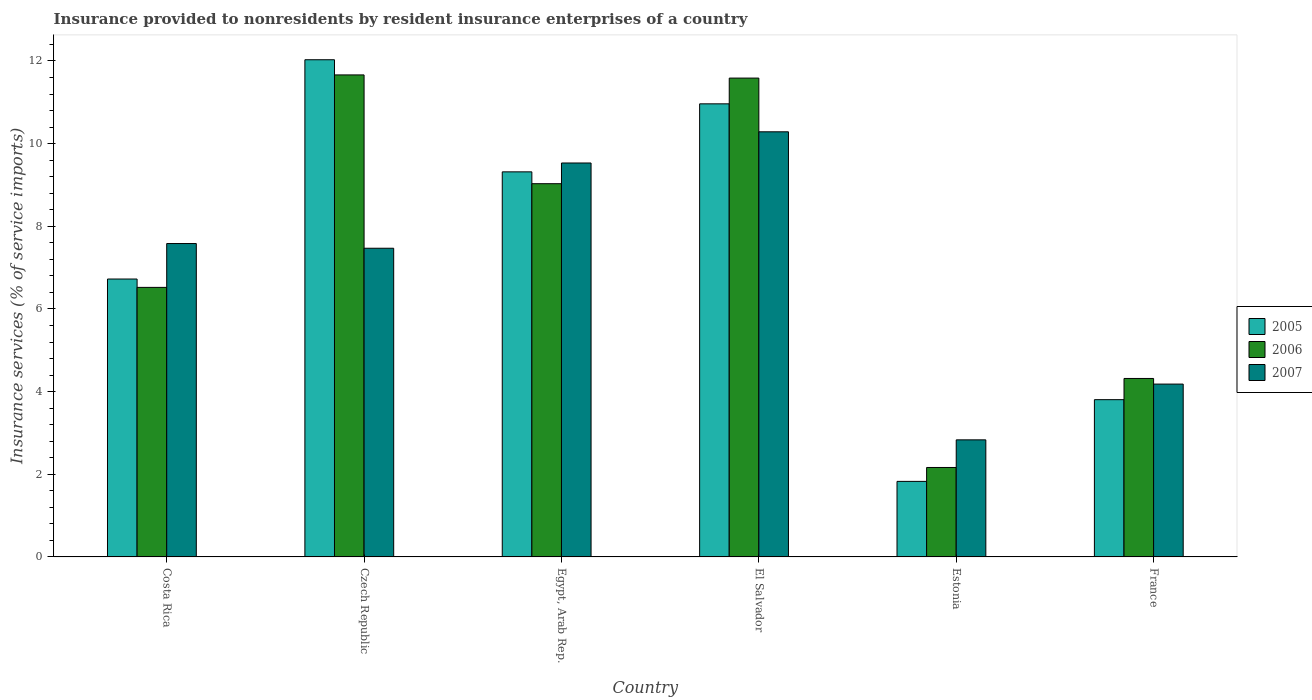How many groups of bars are there?
Your answer should be very brief. 6. How many bars are there on the 3rd tick from the right?
Provide a short and direct response. 3. What is the label of the 5th group of bars from the left?
Offer a very short reply. Estonia. In how many cases, is the number of bars for a given country not equal to the number of legend labels?
Offer a very short reply. 0. What is the insurance provided to nonresidents in 2005 in France?
Your response must be concise. 3.81. Across all countries, what is the maximum insurance provided to nonresidents in 2005?
Provide a succinct answer. 12.03. Across all countries, what is the minimum insurance provided to nonresidents in 2007?
Ensure brevity in your answer.  2.83. In which country was the insurance provided to nonresidents in 2006 maximum?
Provide a short and direct response. Czech Republic. In which country was the insurance provided to nonresidents in 2007 minimum?
Keep it short and to the point. Estonia. What is the total insurance provided to nonresidents in 2005 in the graph?
Ensure brevity in your answer.  44.66. What is the difference between the insurance provided to nonresidents in 2006 in Costa Rica and that in Egypt, Arab Rep.?
Keep it short and to the point. -2.51. What is the difference between the insurance provided to nonresidents in 2006 in Costa Rica and the insurance provided to nonresidents in 2007 in France?
Keep it short and to the point. 2.34. What is the average insurance provided to nonresidents in 2005 per country?
Provide a short and direct response. 7.44. What is the difference between the insurance provided to nonresidents of/in 2005 and insurance provided to nonresidents of/in 2006 in Estonia?
Keep it short and to the point. -0.34. In how many countries, is the insurance provided to nonresidents in 2005 greater than 2 %?
Your answer should be compact. 5. What is the ratio of the insurance provided to nonresidents in 2005 in Egypt, Arab Rep. to that in France?
Keep it short and to the point. 2.45. What is the difference between the highest and the second highest insurance provided to nonresidents in 2007?
Keep it short and to the point. -0.75. What is the difference between the highest and the lowest insurance provided to nonresidents in 2006?
Offer a very short reply. 9.5. What does the 1st bar from the left in Costa Rica represents?
Offer a terse response. 2005. What does the 3rd bar from the right in Estonia represents?
Make the answer very short. 2005. How many bars are there?
Provide a succinct answer. 18. Are all the bars in the graph horizontal?
Ensure brevity in your answer.  No. Does the graph contain grids?
Offer a terse response. No. How are the legend labels stacked?
Your response must be concise. Vertical. What is the title of the graph?
Offer a terse response. Insurance provided to nonresidents by resident insurance enterprises of a country. What is the label or title of the X-axis?
Offer a terse response. Country. What is the label or title of the Y-axis?
Your answer should be compact. Insurance services (% of service imports). What is the Insurance services (% of service imports) in 2005 in Costa Rica?
Offer a terse response. 6.72. What is the Insurance services (% of service imports) of 2006 in Costa Rica?
Your answer should be very brief. 6.52. What is the Insurance services (% of service imports) in 2007 in Costa Rica?
Give a very brief answer. 7.58. What is the Insurance services (% of service imports) of 2005 in Czech Republic?
Offer a very short reply. 12.03. What is the Insurance services (% of service imports) in 2006 in Czech Republic?
Offer a terse response. 11.66. What is the Insurance services (% of service imports) in 2007 in Czech Republic?
Keep it short and to the point. 7.47. What is the Insurance services (% of service imports) in 2005 in Egypt, Arab Rep.?
Provide a short and direct response. 9.32. What is the Insurance services (% of service imports) in 2006 in Egypt, Arab Rep.?
Ensure brevity in your answer.  9.03. What is the Insurance services (% of service imports) in 2007 in Egypt, Arab Rep.?
Offer a terse response. 9.53. What is the Insurance services (% of service imports) of 2005 in El Salvador?
Your answer should be very brief. 10.96. What is the Insurance services (% of service imports) of 2006 in El Salvador?
Make the answer very short. 11.59. What is the Insurance services (% of service imports) in 2007 in El Salvador?
Provide a short and direct response. 10.29. What is the Insurance services (% of service imports) of 2005 in Estonia?
Offer a very short reply. 1.83. What is the Insurance services (% of service imports) in 2006 in Estonia?
Your response must be concise. 2.16. What is the Insurance services (% of service imports) of 2007 in Estonia?
Provide a succinct answer. 2.83. What is the Insurance services (% of service imports) in 2005 in France?
Your response must be concise. 3.81. What is the Insurance services (% of service imports) of 2006 in France?
Keep it short and to the point. 4.32. What is the Insurance services (% of service imports) in 2007 in France?
Ensure brevity in your answer.  4.18. Across all countries, what is the maximum Insurance services (% of service imports) in 2005?
Offer a very short reply. 12.03. Across all countries, what is the maximum Insurance services (% of service imports) in 2006?
Keep it short and to the point. 11.66. Across all countries, what is the maximum Insurance services (% of service imports) in 2007?
Offer a very short reply. 10.29. Across all countries, what is the minimum Insurance services (% of service imports) in 2005?
Provide a short and direct response. 1.83. Across all countries, what is the minimum Insurance services (% of service imports) in 2006?
Ensure brevity in your answer.  2.16. Across all countries, what is the minimum Insurance services (% of service imports) in 2007?
Ensure brevity in your answer.  2.83. What is the total Insurance services (% of service imports) of 2005 in the graph?
Ensure brevity in your answer.  44.66. What is the total Insurance services (% of service imports) in 2006 in the graph?
Offer a very short reply. 45.28. What is the total Insurance services (% of service imports) of 2007 in the graph?
Your answer should be compact. 41.88. What is the difference between the Insurance services (% of service imports) of 2005 in Costa Rica and that in Czech Republic?
Your response must be concise. -5.31. What is the difference between the Insurance services (% of service imports) in 2006 in Costa Rica and that in Czech Republic?
Offer a terse response. -5.14. What is the difference between the Insurance services (% of service imports) of 2007 in Costa Rica and that in Czech Republic?
Provide a succinct answer. 0.11. What is the difference between the Insurance services (% of service imports) in 2005 in Costa Rica and that in Egypt, Arab Rep.?
Offer a very short reply. -2.59. What is the difference between the Insurance services (% of service imports) in 2006 in Costa Rica and that in Egypt, Arab Rep.?
Ensure brevity in your answer.  -2.51. What is the difference between the Insurance services (% of service imports) of 2007 in Costa Rica and that in Egypt, Arab Rep.?
Provide a short and direct response. -1.95. What is the difference between the Insurance services (% of service imports) in 2005 in Costa Rica and that in El Salvador?
Give a very brief answer. -4.24. What is the difference between the Insurance services (% of service imports) in 2006 in Costa Rica and that in El Salvador?
Provide a short and direct response. -5.06. What is the difference between the Insurance services (% of service imports) of 2007 in Costa Rica and that in El Salvador?
Your answer should be compact. -2.7. What is the difference between the Insurance services (% of service imports) in 2005 in Costa Rica and that in Estonia?
Offer a terse response. 4.9. What is the difference between the Insurance services (% of service imports) of 2006 in Costa Rica and that in Estonia?
Give a very brief answer. 4.36. What is the difference between the Insurance services (% of service imports) in 2007 in Costa Rica and that in Estonia?
Give a very brief answer. 4.75. What is the difference between the Insurance services (% of service imports) in 2005 in Costa Rica and that in France?
Offer a terse response. 2.92. What is the difference between the Insurance services (% of service imports) in 2006 in Costa Rica and that in France?
Offer a terse response. 2.2. What is the difference between the Insurance services (% of service imports) of 2007 in Costa Rica and that in France?
Keep it short and to the point. 3.4. What is the difference between the Insurance services (% of service imports) of 2005 in Czech Republic and that in Egypt, Arab Rep.?
Your response must be concise. 2.71. What is the difference between the Insurance services (% of service imports) of 2006 in Czech Republic and that in Egypt, Arab Rep.?
Make the answer very short. 2.63. What is the difference between the Insurance services (% of service imports) of 2007 in Czech Republic and that in Egypt, Arab Rep.?
Offer a very short reply. -2.06. What is the difference between the Insurance services (% of service imports) in 2005 in Czech Republic and that in El Salvador?
Ensure brevity in your answer.  1.07. What is the difference between the Insurance services (% of service imports) in 2006 in Czech Republic and that in El Salvador?
Keep it short and to the point. 0.08. What is the difference between the Insurance services (% of service imports) of 2007 in Czech Republic and that in El Salvador?
Your response must be concise. -2.82. What is the difference between the Insurance services (% of service imports) in 2005 in Czech Republic and that in Estonia?
Offer a terse response. 10.2. What is the difference between the Insurance services (% of service imports) of 2006 in Czech Republic and that in Estonia?
Keep it short and to the point. 9.5. What is the difference between the Insurance services (% of service imports) in 2007 in Czech Republic and that in Estonia?
Your answer should be very brief. 4.64. What is the difference between the Insurance services (% of service imports) in 2005 in Czech Republic and that in France?
Provide a succinct answer. 8.22. What is the difference between the Insurance services (% of service imports) in 2006 in Czech Republic and that in France?
Your answer should be compact. 7.34. What is the difference between the Insurance services (% of service imports) in 2007 in Czech Republic and that in France?
Your answer should be very brief. 3.29. What is the difference between the Insurance services (% of service imports) in 2005 in Egypt, Arab Rep. and that in El Salvador?
Your response must be concise. -1.65. What is the difference between the Insurance services (% of service imports) of 2006 in Egypt, Arab Rep. and that in El Salvador?
Provide a short and direct response. -2.56. What is the difference between the Insurance services (% of service imports) in 2007 in Egypt, Arab Rep. and that in El Salvador?
Make the answer very short. -0.75. What is the difference between the Insurance services (% of service imports) in 2005 in Egypt, Arab Rep. and that in Estonia?
Make the answer very short. 7.49. What is the difference between the Insurance services (% of service imports) of 2006 in Egypt, Arab Rep. and that in Estonia?
Give a very brief answer. 6.87. What is the difference between the Insurance services (% of service imports) of 2007 in Egypt, Arab Rep. and that in Estonia?
Keep it short and to the point. 6.7. What is the difference between the Insurance services (% of service imports) of 2005 in Egypt, Arab Rep. and that in France?
Ensure brevity in your answer.  5.51. What is the difference between the Insurance services (% of service imports) in 2006 in Egypt, Arab Rep. and that in France?
Offer a terse response. 4.71. What is the difference between the Insurance services (% of service imports) in 2007 in Egypt, Arab Rep. and that in France?
Offer a very short reply. 5.35. What is the difference between the Insurance services (% of service imports) of 2005 in El Salvador and that in Estonia?
Your answer should be compact. 9.13. What is the difference between the Insurance services (% of service imports) of 2006 in El Salvador and that in Estonia?
Offer a terse response. 9.42. What is the difference between the Insurance services (% of service imports) of 2007 in El Salvador and that in Estonia?
Ensure brevity in your answer.  7.45. What is the difference between the Insurance services (% of service imports) of 2005 in El Salvador and that in France?
Your answer should be very brief. 7.16. What is the difference between the Insurance services (% of service imports) in 2006 in El Salvador and that in France?
Your answer should be compact. 7.27. What is the difference between the Insurance services (% of service imports) in 2007 in El Salvador and that in France?
Your answer should be very brief. 6.1. What is the difference between the Insurance services (% of service imports) in 2005 in Estonia and that in France?
Provide a short and direct response. -1.98. What is the difference between the Insurance services (% of service imports) in 2006 in Estonia and that in France?
Provide a short and direct response. -2.15. What is the difference between the Insurance services (% of service imports) of 2007 in Estonia and that in France?
Your answer should be very brief. -1.35. What is the difference between the Insurance services (% of service imports) in 2005 in Costa Rica and the Insurance services (% of service imports) in 2006 in Czech Republic?
Make the answer very short. -4.94. What is the difference between the Insurance services (% of service imports) of 2005 in Costa Rica and the Insurance services (% of service imports) of 2007 in Czech Republic?
Make the answer very short. -0.74. What is the difference between the Insurance services (% of service imports) in 2006 in Costa Rica and the Insurance services (% of service imports) in 2007 in Czech Republic?
Make the answer very short. -0.95. What is the difference between the Insurance services (% of service imports) of 2005 in Costa Rica and the Insurance services (% of service imports) of 2006 in Egypt, Arab Rep.?
Your response must be concise. -2.31. What is the difference between the Insurance services (% of service imports) in 2005 in Costa Rica and the Insurance services (% of service imports) in 2007 in Egypt, Arab Rep.?
Give a very brief answer. -2.81. What is the difference between the Insurance services (% of service imports) of 2006 in Costa Rica and the Insurance services (% of service imports) of 2007 in Egypt, Arab Rep.?
Your answer should be compact. -3.01. What is the difference between the Insurance services (% of service imports) of 2005 in Costa Rica and the Insurance services (% of service imports) of 2006 in El Salvador?
Provide a short and direct response. -4.86. What is the difference between the Insurance services (% of service imports) of 2005 in Costa Rica and the Insurance services (% of service imports) of 2007 in El Salvador?
Offer a terse response. -3.56. What is the difference between the Insurance services (% of service imports) of 2006 in Costa Rica and the Insurance services (% of service imports) of 2007 in El Salvador?
Keep it short and to the point. -3.76. What is the difference between the Insurance services (% of service imports) of 2005 in Costa Rica and the Insurance services (% of service imports) of 2006 in Estonia?
Make the answer very short. 4.56. What is the difference between the Insurance services (% of service imports) in 2005 in Costa Rica and the Insurance services (% of service imports) in 2007 in Estonia?
Ensure brevity in your answer.  3.89. What is the difference between the Insurance services (% of service imports) of 2006 in Costa Rica and the Insurance services (% of service imports) of 2007 in Estonia?
Keep it short and to the point. 3.69. What is the difference between the Insurance services (% of service imports) in 2005 in Costa Rica and the Insurance services (% of service imports) in 2006 in France?
Offer a very short reply. 2.41. What is the difference between the Insurance services (% of service imports) of 2005 in Costa Rica and the Insurance services (% of service imports) of 2007 in France?
Ensure brevity in your answer.  2.54. What is the difference between the Insurance services (% of service imports) of 2006 in Costa Rica and the Insurance services (% of service imports) of 2007 in France?
Your response must be concise. 2.34. What is the difference between the Insurance services (% of service imports) of 2005 in Czech Republic and the Insurance services (% of service imports) of 2006 in Egypt, Arab Rep.?
Your response must be concise. 3. What is the difference between the Insurance services (% of service imports) in 2005 in Czech Republic and the Insurance services (% of service imports) in 2007 in Egypt, Arab Rep.?
Offer a terse response. 2.5. What is the difference between the Insurance services (% of service imports) in 2006 in Czech Republic and the Insurance services (% of service imports) in 2007 in Egypt, Arab Rep.?
Provide a short and direct response. 2.13. What is the difference between the Insurance services (% of service imports) of 2005 in Czech Republic and the Insurance services (% of service imports) of 2006 in El Salvador?
Provide a succinct answer. 0.44. What is the difference between the Insurance services (% of service imports) in 2005 in Czech Republic and the Insurance services (% of service imports) in 2007 in El Salvador?
Provide a succinct answer. 1.74. What is the difference between the Insurance services (% of service imports) in 2006 in Czech Republic and the Insurance services (% of service imports) in 2007 in El Salvador?
Offer a terse response. 1.38. What is the difference between the Insurance services (% of service imports) in 2005 in Czech Republic and the Insurance services (% of service imports) in 2006 in Estonia?
Make the answer very short. 9.87. What is the difference between the Insurance services (% of service imports) of 2005 in Czech Republic and the Insurance services (% of service imports) of 2007 in Estonia?
Provide a succinct answer. 9.2. What is the difference between the Insurance services (% of service imports) of 2006 in Czech Republic and the Insurance services (% of service imports) of 2007 in Estonia?
Offer a very short reply. 8.83. What is the difference between the Insurance services (% of service imports) in 2005 in Czech Republic and the Insurance services (% of service imports) in 2006 in France?
Make the answer very short. 7.71. What is the difference between the Insurance services (% of service imports) of 2005 in Czech Republic and the Insurance services (% of service imports) of 2007 in France?
Your answer should be very brief. 7.85. What is the difference between the Insurance services (% of service imports) of 2006 in Czech Republic and the Insurance services (% of service imports) of 2007 in France?
Provide a succinct answer. 7.48. What is the difference between the Insurance services (% of service imports) of 2005 in Egypt, Arab Rep. and the Insurance services (% of service imports) of 2006 in El Salvador?
Offer a terse response. -2.27. What is the difference between the Insurance services (% of service imports) of 2005 in Egypt, Arab Rep. and the Insurance services (% of service imports) of 2007 in El Salvador?
Offer a terse response. -0.97. What is the difference between the Insurance services (% of service imports) of 2006 in Egypt, Arab Rep. and the Insurance services (% of service imports) of 2007 in El Salvador?
Offer a terse response. -1.26. What is the difference between the Insurance services (% of service imports) in 2005 in Egypt, Arab Rep. and the Insurance services (% of service imports) in 2006 in Estonia?
Offer a very short reply. 7.15. What is the difference between the Insurance services (% of service imports) of 2005 in Egypt, Arab Rep. and the Insurance services (% of service imports) of 2007 in Estonia?
Make the answer very short. 6.48. What is the difference between the Insurance services (% of service imports) of 2006 in Egypt, Arab Rep. and the Insurance services (% of service imports) of 2007 in Estonia?
Offer a very short reply. 6.2. What is the difference between the Insurance services (% of service imports) of 2005 in Egypt, Arab Rep. and the Insurance services (% of service imports) of 2006 in France?
Give a very brief answer. 5. What is the difference between the Insurance services (% of service imports) in 2005 in Egypt, Arab Rep. and the Insurance services (% of service imports) in 2007 in France?
Your answer should be compact. 5.13. What is the difference between the Insurance services (% of service imports) in 2006 in Egypt, Arab Rep. and the Insurance services (% of service imports) in 2007 in France?
Ensure brevity in your answer.  4.85. What is the difference between the Insurance services (% of service imports) of 2005 in El Salvador and the Insurance services (% of service imports) of 2006 in Estonia?
Make the answer very short. 8.8. What is the difference between the Insurance services (% of service imports) of 2005 in El Salvador and the Insurance services (% of service imports) of 2007 in Estonia?
Your answer should be compact. 8.13. What is the difference between the Insurance services (% of service imports) in 2006 in El Salvador and the Insurance services (% of service imports) in 2007 in Estonia?
Your response must be concise. 8.75. What is the difference between the Insurance services (% of service imports) in 2005 in El Salvador and the Insurance services (% of service imports) in 2006 in France?
Provide a succinct answer. 6.64. What is the difference between the Insurance services (% of service imports) of 2005 in El Salvador and the Insurance services (% of service imports) of 2007 in France?
Your response must be concise. 6.78. What is the difference between the Insurance services (% of service imports) of 2006 in El Salvador and the Insurance services (% of service imports) of 2007 in France?
Keep it short and to the point. 7.4. What is the difference between the Insurance services (% of service imports) in 2005 in Estonia and the Insurance services (% of service imports) in 2006 in France?
Your answer should be compact. -2.49. What is the difference between the Insurance services (% of service imports) in 2005 in Estonia and the Insurance services (% of service imports) in 2007 in France?
Your response must be concise. -2.35. What is the difference between the Insurance services (% of service imports) in 2006 in Estonia and the Insurance services (% of service imports) in 2007 in France?
Your answer should be very brief. -2.02. What is the average Insurance services (% of service imports) of 2005 per country?
Your answer should be very brief. 7.44. What is the average Insurance services (% of service imports) in 2006 per country?
Keep it short and to the point. 7.55. What is the average Insurance services (% of service imports) of 2007 per country?
Your response must be concise. 6.98. What is the difference between the Insurance services (% of service imports) in 2005 and Insurance services (% of service imports) in 2006 in Costa Rica?
Ensure brevity in your answer.  0.2. What is the difference between the Insurance services (% of service imports) of 2005 and Insurance services (% of service imports) of 2007 in Costa Rica?
Your response must be concise. -0.86. What is the difference between the Insurance services (% of service imports) in 2006 and Insurance services (% of service imports) in 2007 in Costa Rica?
Keep it short and to the point. -1.06. What is the difference between the Insurance services (% of service imports) of 2005 and Insurance services (% of service imports) of 2006 in Czech Republic?
Offer a very short reply. 0.37. What is the difference between the Insurance services (% of service imports) of 2005 and Insurance services (% of service imports) of 2007 in Czech Republic?
Provide a short and direct response. 4.56. What is the difference between the Insurance services (% of service imports) of 2006 and Insurance services (% of service imports) of 2007 in Czech Republic?
Keep it short and to the point. 4.19. What is the difference between the Insurance services (% of service imports) in 2005 and Insurance services (% of service imports) in 2006 in Egypt, Arab Rep.?
Ensure brevity in your answer.  0.29. What is the difference between the Insurance services (% of service imports) of 2005 and Insurance services (% of service imports) of 2007 in Egypt, Arab Rep.?
Keep it short and to the point. -0.21. What is the difference between the Insurance services (% of service imports) of 2006 and Insurance services (% of service imports) of 2007 in Egypt, Arab Rep.?
Give a very brief answer. -0.5. What is the difference between the Insurance services (% of service imports) of 2005 and Insurance services (% of service imports) of 2006 in El Salvador?
Keep it short and to the point. -0.62. What is the difference between the Insurance services (% of service imports) of 2005 and Insurance services (% of service imports) of 2007 in El Salvador?
Give a very brief answer. 0.68. What is the difference between the Insurance services (% of service imports) of 2006 and Insurance services (% of service imports) of 2007 in El Salvador?
Offer a terse response. 1.3. What is the difference between the Insurance services (% of service imports) of 2005 and Insurance services (% of service imports) of 2006 in Estonia?
Provide a succinct answer. -0.34. What is the difference between the Insurance services (% of service imports) of 2005 and Insurance services (% of service imports) of 2007 in Estonia?
Ensure brevity in your answer.  -1.01. What is the difference between the Insurance services (% of service imports) of 2006 and Insurance services (% of service imports) of 2007 in Estonia?
Your response must be concise. -0.67. What is the difference between the Insurance services (% of service imports) in 2005 and Insurance services (% of service imports) in 2006 in France?
Offer a very short reply. -0.51. What is the difference between the Insurance services (% of service imports) in 2005 and Insurance services (% of service imports) in 2007 in France?
Provide a succinct answer. -0.38. What is the difference between the Insurance services (% of service imports) in 2006 and Insurance services (% of service imports) in 2007 in France?
Provide a succinct answer. 0.14. What is the ratio of the Insurance services (% of service imports) in 2005 in Costa Rica to that in Czech Republic?
Offer a terse response. 0.56. What is the ratio of the Insurance services (% of service imports) of 2006 in Costa Rica to that in Czech Republic?
Provide a short and direct response. 0.56. What is the ratio of the Insurance services (% of service imports) in 2007 in Costa Rica to that in Czech Republic?
Make the answer very short. 1.02. What is the ratio of the Insurance services (% of service imports) of 2005 in Costa Rica to that in Egypt, Arab Rep.?
Your answer should be compact. 0.72. What is the ratio of the Insurance services (% of service imports) in 2006 in Costa Rica to that in Egypt, Arab Rep.?
Your answer should be compact. 0.72. What is the ratio of the Insurance services (% of service imports) of 2007 in Costa Rica to that in Egypt, Arab Rep.?
Offer a terse response. 0.8. What is the ratio of the Insurance services (% of service imports) in 2005 in Costa Rica to that in El Salvador?
Your answer should be very brief. 0.61. What is the ratio of the Insurance services (% of service imports) of 2006 in Costa Rica to that in El Salvador?
Give a very brief answer. 0.56. What is the ratio of the Insurance services (% of service imports) of 2007 in Costa Rica to that in El Salvador?
Your response must be concise. 0.74. What is the ratio of the Insurance services (% of service imports) of 2005 in Costa Rica to that in Estonia?
Provide a short and direct response. 3.68. What is the ratio of the Insurance services (% of service imports) in 2006 in Costa Rica to that in Estonia?
Provide a short and direct response. 3.01. What is the ratio of the Insurance services (% of service imports) in 2007 in Costa Rica to that in Estonia?
Offer a very short reply. 2.68. What is the ratio of the Insurance services (% of service imports) in 2005 in Costa Rica to that in France?
Provide a succinct answer. 1.77. What is the ratio of the Insurance services (% of service imports) of 2006 in Costa Rica to that in France?
Ensure brevity in your answer.  1.51. What is the ratio of the Insurance services (% of service imports) of 2007 in Costa Rica to that in France?
Your answer should be very brief. 1.81. What is the ratio of the Insurance services (% of service imports) in 2005 in Czech Republic to that in Egypt, Arab Rep.?
Offer a terse response. 1.29. What is the ratio of the Insurance services (% of service imports) of 2006 in Czech Republic to that in Egypt, Arab Rep.?
Your answer should be compact. 1.29. What is the ratio of the Insurance services (% of service imports) in 2007 in Czech Republic to that in Egypt, Arab Rep.?
Your answer should be compact. 0.78. What is the ratio of the Insurance services (% of service imports) in 2005 in Czech Republic to that in El Salvador?
Offer a very short reply. 1.1. What is the ratio of the Insurance services (% of service imports) of 2006 in Czech Republic to that in El Salvador?
Ensure brevity in your answer.  1.01. What is the ratio of the Insurance services (% of service imports) of 2007 in Czech Republic to that in El Salvador?
Offer a very short reply. 0.73. What is the ratio of the Insurance services (% of service imports) of 2005 in Czech Republic to that in Estonia?
Keep it short and to the point. 6.58. What is the ratio of the Insurance services (% of service imports) in 2006 in Czech Republic to that in Estonia?
Your answer should be very brief. 5.39. What is the ratio of the Insurance services (% of service imports) of 2007 in Czech Republic to that in Estonia?
Offer a very short reply. 2.64. What is the ratio of the Insurance services (% of service imports) in 2005 in Czech Republic to that in France?
Provide a succinct answer. 3.16. What is the ratio of the Insurance services (% of service imports) of 2006 in Czech Republic to that in France?
Your answer should be very brief. 2.7. What is the ratio of the Insurance services (% of service imports) of 2007 in Czech Republic to that in France?
Your response must be concise. 1.79. What is the ratio of the Insurance services (% of service imports) in 2005 in Egypt, Arab Rep. to that in El Salvador?
Make the answer very short. 0.85. What is the ratio of the Insurance services (% of service imports) in 2006 in Egypt, Arab Rep. to that in El Salvador?
Ensure brevity in your answer.  0.78. What is the ratio of the Insurance services (% of service imports) in 2007 in Egypt, Arab Rep. to that in El Salvador?
Ensure brevity in your answer.  0.93. What is the ratio of the Insurance services (% of service imports) in 2005 in Egypt, Arab Rep. to that in Estonia?
Offer a very short reply. 5.1. What is the ratio of the Insurance services (% of service imports) of 2006 in Egypt, Arab Rep. to that in Estonia?
Give a very brief answer. 4.17. What is the ratio of the Insurance services (% of service imports) in 2007 in Egypt, Arab Rep. to that in Estonia?
Provide a succinct answer. 3.36. What is the ratio of the Insurance services (% of service imports) of 2005 in Egypt, Arab Rep. to that in France?
Offer a terse response. 2.45. What is the ratio of the Insurance services (% of service imports) in 2006 in Egypt, Arab Rep. to that in France?
Make the answer very short. 2.09. What is the ratio of the Insurance services (% of service imports) of 2007 in Egypt, Arab Rep. to that in France?
Provide a succinct answer. 2.28. What is the ratio of the Insurance services (% of service imports) in 2005 in El Salvador to that in Estonia?
Offer a terse response. 6. What is the ratio of the Insurance services (% of service imports) in 2006 in El Salvador to that in Estonia?
Your response must be concise. 5.35. What is the ratio of the Insurance services (% of service imports) in 2007 in El Salvador to that in Estonia?
Offer a terse response. 3.63. What is the ratio of the Insurance services (% of service imports) in 2005 in El Salvador to that in France?
Your response must be concise. 2.88. What is the ratio of the Insurance services (% of service imports) in 2006 in El Salvador to that in France?
Offer a very short reply. 2.68. What is the ratio of the Insurance services (% of service imports) of 2007 in El Salvador to that in France?
Offer a very short reply. 2.46. What is the ratio of the Insurance services (% of service imports) of 2005 in Estonia to that in France?
Provide a short and direct response. 0.48. What is the ratio of the Insurance services (% of service imports) in 2006 in Estonia to that in France?
Make the answer very short. 0.5. What is the ratio of the Insurance services (% of service imports) in 2007 in Estonia to that in France?
Keep it short and to the point. 0.68. What is the difference between the highest and the second highest Insurance services (% of service imports) in 2005?
Your response must be concise. 1.07. What is the difference between the highest and the second highest Insurance services (% of service imports) of 2006?
Your response must be concise. 0.08. What is the difference between the highest and the second highest Insurance services (% of service imports) in 2007?
Give a very brief answer. 0.75. What is the difference between the highest and the lowest Insurance services (% of service imports) of 2005?
Your answer should be very brief. 10.2. What is the difference between the highest and the lowest Insurance services (% of service imports) in 2006?
Make the answer very short. 9.5. What is the difference between the highest and the lowest Insurance services (% of service imports) of 2007?
Your answer should be compact. 7.45. 